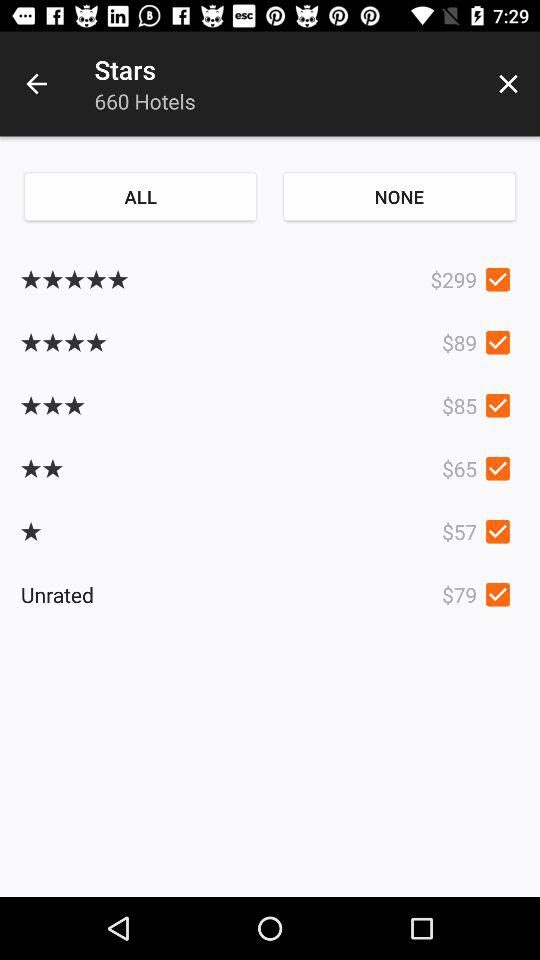What is the cost of the five star hotels? The cost of the five star hotel is $299. 